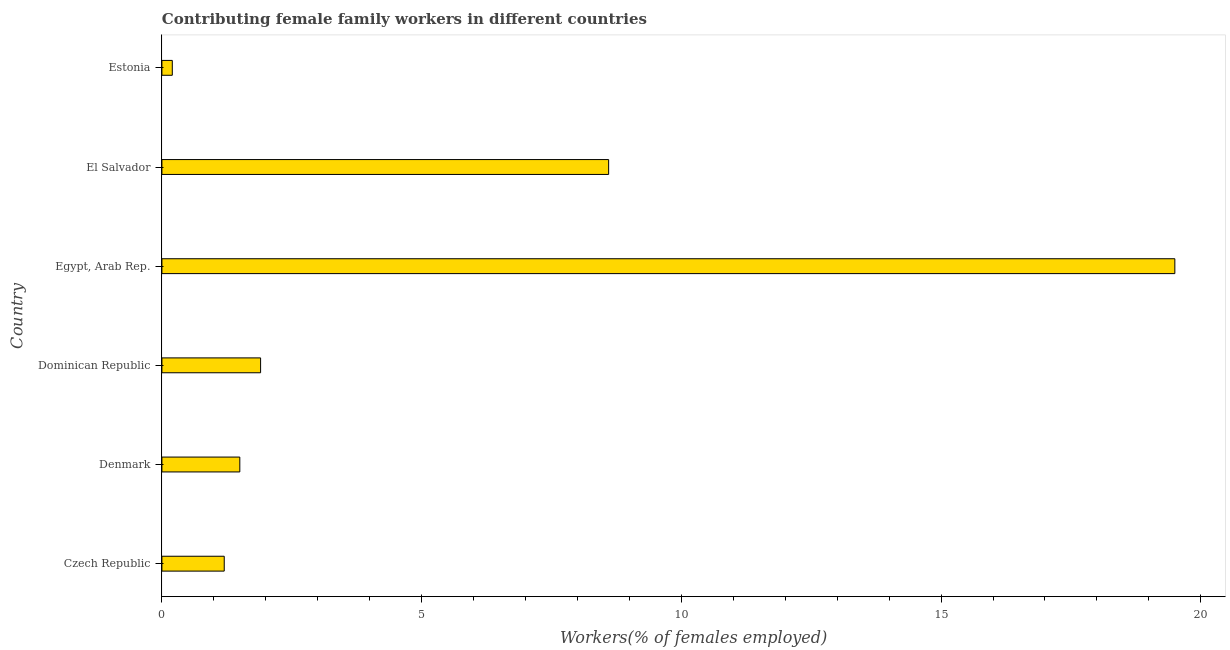What is the title of the graph?
Offer a terse response. Contributing female family workers in different countries. What is the label or title of the X-axis?
Offer a terse response. Workers(% of females employed). What is the contributing female family workers in Estonia?
Ensure brevity in your answer.  0.2. Across all countries, what is the minimum contributing female family workers?
Keep it short and to the point. 0.2. In which country was the contributing female family workers maximum?
Give a very brief answer. Egypt, Arab Rep. In which country was the contributing female family workers minimum?
Provide a short and direct response. Estonia. What is the sum of the contributing female family workers?
Offer a very short reply. 32.9. What is the difference between the contributing female family workers in Czech Republic and Dominican Republic?
Keep it short and to the point. -0.7. What is the average contributing female family workers per country?
Ensure brevity in your answer.  5.48. What is the median contributing female family workers?
Ensure brevity in your answer.  1.7. Is the contributing female family workers in Czech Republic less than that in El Salvador?
Your response must be concise. Yes. What is the difference between the highest and the second highest contributing female family workers?
Provide a succinct answer. 10.9. What is the difference between the highest and the lowest contributing female family workers?
Your response must be concise. 19.3. How many bars are there?
Your response must be concise. 6. What is the difference between two consecutive major ticks on the X-axis?
Make the answer very short. 5. Are the values on the major ticks of X-axis written in scientific E-notation?
Ensure brevity in your answer.  No. What is the Workers(% of females employed) in Czech Republic?
Ensure brevity in your answer.  1.2. What is the Workers(% of females employed) of Dominican Republic?
Offer a very short reply. 1.9. What is the Workers(% of females employed) of El Salvador?
Keep it short and to the point. 8.6. What is the Workers(% of females employed) of Estonia?
Provide a short and direct response. 0.2. What is the difference between the Workers(% of females employed) in Czech Republic and Egypt, Arab Rep.?
Your answer should be very brief. -18.3. What is the difference between the Workers(% of females employed) in Czech Republic and Estonia?
Ensure brevity in your answer.  1. What is the difference between the Workers(% of females employed) in Denmark and Egypt, Arab Rep.?
Offer a very short reply. -18. What is the difference between the Workers(% of females employed) in Denmark and Estonia?
Give a very brief answer. 1.3. What is the difference between the Workers(% of females employed) in Dominican Republic and Egypt, Arab Rep.?
Your answer should be very brief. -17.6. What is the difference between the Workers(% of females employed) in Dominican Republic and Estonia?
Ensure brevity in your answer.  1.7. What is the difference between the Workers(% of females employed) in Egypt, Arab Rep. and El Salvador?
Your response must be concise. 10.9. What is the difference between the Workers(% of females employed) in Egypt, Arab Rep. and Estonia?
Your answer should be very brief. 19.3. What is the difference between the Workers(% of females employed) in El Salvador and Estonia?
Offer a very short reply. 8.4. What is the ratio of the Workers(% of females employed) in Czech Republic to that in Dominican Republic?
Your answer should be very brief. 0.63. What is the ratio of the Workers(% of females employed) in Czech Republic to that in Egypt, Arab Rep.?
Offer a very short reply. 0.06. What is the ratio of the Workers(% of females employed) in Czech Republic to that in El Salvador?
Your answer should be compact. 0.14. What is the ratio of the Workers(% of females employed) in Denmark to that in Dominican Republic?
Ensure brevity in your answer.  0.79. What is the ratio of the Workers(% of females employed) in Denmark to that in Egypt, Arab Rep.?
Make the answer very short. 0.08. What is the ratio of the Workers(% of females employed) in Denmark to that in El Salvador?
Ensure brevity in your answer.  0.17. What is the ratio of the Workers(% of females employed) in Dominican Republic to that in Egypt, Arab Rep.?
Ensure brevity in your answer.  0.1. What is the ratio of the Workers(% of females employed) in Dominican Republic to that in El Salvador?
Offer a very short reply. 0.22. What is the ratio of the Workers(% of females employed) in Dominican Republic to that in Estonia?
Your answer should be compact. 9.5. What is the ratio of the Workers(% of females employed) in Egypt, Arab Rep. to that in El Salvador?
Make the answer very short. 2.27. What is the ratio of the Workers(% of females employed) in Egypt, Arab Rep. to that in Estonia?
Provide a short and direct response. 97.5. 